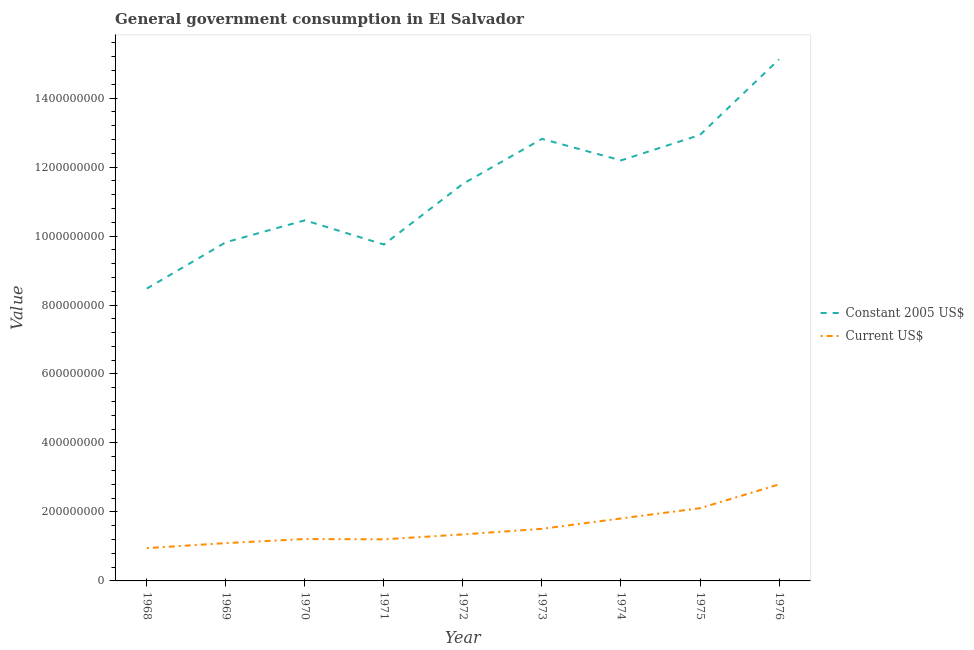How many different coloured lines are there?
Provide a short and direct response. 2. What is the value consumed in constant 2005 us$ in 1973?
Keep it short and to the point. 1.28e+09. Across all years, what is the maximum value consumed in current us$?
Provide a succinct answer. 2.80e+08. Across all years, what is the minimum value consumed in current us$?
Your response must be concise. 9.51e+07. In which year was the value consumed in current us$ maximum?
Offer a very short reply. 1976. In which year was the value consumed in constant 2005 us$ minimum?
Give a very brief answer. 1968. What is the total value consumed in constant 2005 us$ in the graph?
Keep it short and to the point. 1.03e+1. What is the difference between the value consumed in constant 2005 us$ in 1972 and that in 1975?
Your answer should be very brief. -1.42e+08. What is the difference between the value consumed in current us$ in 1972 and the value consumed in constant 2005 us$ in 1975?
Ensure brevity in your answer.  -1.16e+09. What is the average value consumed in current us$ per year?
Offer a very short reply. 1.56e+08. In the year 1975, what is the difference between the value consumed in constant 2005 us$ and value consumed in current us$?
Your answer should be compact. 1.08e+09. In how many years, is the value consumed in constant 2005 us$ greater than 1440000000?
Offer a very short reply. 1. What is the ratio of the value consumed in current us$ in 1973 to that in 1976?
Provide a short and direct response. 0.54. Is the value consumed in constant 2005 us$ in 1970 less than that in 1976?
Provide a succinct answer. Yes. Is the difference between the value consumed in current us$ in 1969 and 1974 greater than the difference between the value consumed in constant 2005 us$ in 1969 and 1974?
Ensure brevity in your answer.  Yes. What is the difference between the highest and the second highest value consumed in constant 2005 us$?
Your response must be concise. 2.19e+08. What is the difference between the highest and the lowest value consumed in current us$?
Ensure brevity in your answer.  1.85e+08. In how many years, is the value consumed in constant 2005 us$ greater than the average value consumed in constant 2005 us$ taken over all years?
Offer a terse response. 5. Is the sum of the value consumed in current us$ in 1969 and 1972 greater than the maximum value consumed in constant 2005 us$ across all years?
Your response must be concise. No. Does the value consumed in constant 2005 us$ monotonically increase over the years?
Ensure brevity in your answer.  No. Is the value consumed in current us$ strictly greater than the value consumed in constant 2005 us$ over the years?
Keep it short and to the point. No. Does the graph contain grids?
Offer a very short reply. No. Where does the legend appear in the graph?
Make the answer very short. Center right. How many legend labels are there?
Offer a terse response. 2. How are the legend labels stacked?
Your response must be concise. Vertical. What is the title of the graph?
Give a very brief answer. General government consumption in El Salvador. Does "Nonresident" appear as one of the legend labels in the graph?
Your response must be concise. No. What is the label or title of the Y-axis?
Your answer should be very brief. Value. What is the Value of Constant 2005 US$ in 1968?
Your answer should be compact. 8.48e+08. What is the Value of Current US$ in 1968?
Your answer should be very brief. 9.51e+07. What is the Value in Constant 2005 US$ in 1969?
Provide a succinct answer. 9.82e+08. What is the Value in Current US$ in 1969?
Offer a very short reply. 1.10e+08. What is the Value of Constant 2005 US$ in 1970?
Ensure brevity in your answer.  1.05e+09. What is the Value of Current US$ in 1970?
Keep it short and to the point. 1.21e+08. What is the Value of Constant 2005 US$ in 1971?
Make the answer very short. 9.75e+08. What is the Value of Current US$ in 1971?
Provide a short and direct response. 1.21e+08. What is the Value in Constant 2005 US$ in 1972?
Offer a very short reply. 1.15e+09. What is the Value in Current US$ in 1972?
Provide a short and direct response. 1.35e+08. What is the Value in Constant 2005 US$ in 1973?
Make the answer very short. 1.28e+09. What is the Value of Current US$ in 1973?
Offer a terse response. 1.51e+08. What is the Value in Constant 2005 US$ in 1974?
Keep it short and to the point. 1.22e+09. What is the Value in Current US$ in 1974?
Give a very brief answer. 1.81e+08. What is the Value of Constant 2005 US$ in 1975?
Your response must be concise. 1.29e+09. What is the Value in Current US$ in 1975?
Provide a short and direct response. 2.11e+08. What is the Value in Constant 2005 US$ in 1976?
Offer a terse response. 1.51e+09. What is the Value in Current US$ in 1976?
Provide a succinct answer. 2.80e+08. Across all years, what is the maximum Value of Constant 2005 US$?
Offer a very short reply. 1.51e+09. Across all years, what is the maximum Value in Current US$?
Make the answer very short. 2.80e+08. Across all years, what is the minimum Value of Constant 2005 US$?
Offer a terse response. 8.48e+08. Across all years, what is the minimum Value of Current US$?
Provide a succinct answer. 9.51e+07. What is the total Value in Constant 2005 US$ in the graph?
Keep it short and to the point. 1.03e+1. What is the total Value in Current US$ in the graph?
Provide a succinct answer. 1.40e+09. What is the difference between the Value in Constant 2005 US$ in 1968 and that in 1969?
Provide a short and direct response. -1.34e+08. What is the difference between the Value of Current US$ in 1968 and that in 1969?
Keep it short and to the point. -1.46e+07. What is the difference between the Value in Constant 2005 US$ in 1968 and that in 1970?
Offer a terse response. -1.98e+08. What is the difference between the Value in Current US$ in 1968 and that in 1970?
Give a very brief answer. -2.64e+07. What is the difference between the Value of Constant 2005 US$ in 1968 and that in 1971?
Make the answer very short. -1.28e+08. What is the difference between the Value in Current US$ in 1968 and that in 1971?
Keep it short and to the point. -2.55e+07. What is the difference between the Value in Constant 2005 US$ in 1968 and that in 1972?
Give a very brief answer. -3.04e+08. What is the difference between the Value in Current US$ in 1968 and that in 1972?
Keep it short and to the point. -3.98e+07. What is the difference between the Value in Constant 2005 US$ in 1968 and that in 1973?
Keep it short and to the point. -4.34e+08. What is the difference between the Value of Current US$ in 1968 and that in 1973?
Keep it short and to the point. -5.60e+07. What is the difference between the Value of Constant 2005 US$ in 1968 and that in 1974?
Give a very brief answer. -3.72e+08. What is the difference between the Value in Current US$ in 1968 and that in 1974?
Your response must be concise. -8.60e+07. What is the difference between the Value of Constant 2005 US$ in 1968 and that in 1975?
Provide a short and direct response. -4.46e+08. What is the difference between the Value in Current US$ in 1968 and that in 1975?
Give a very brief answer. -1.16e+08. What is the difference between the Value in Constant 2005 US$ in 1968 and that in 1976?
Give a very brief answer. -6.65e+08. What is the difference between the Value in Current US$ in 1968 and that in 1976?
Give a very brief answer. -1.85e+08. What is the difference between the Value in Constant 2005 US$ in 1969 and that in 1970?
Keep it short and to the point. -6.37e+07. What is the difference between the Value of Current US$ in 1969 and that in 1970?
Ensure brevity in your answer.  -1.18e+07. What is the difference between the Value in Constant 2005 US$ in 1969 and that in 1971?
Provide a short and direct response. 6.57e+06. What is the difference between the Value in Current US$ in 1969 and that in 1971?
Provide a short and direct response. -1.10e+07. What is the difference between the Value of Constant 2005 US$ in 1969 and that in 1972?
Provide a succinct answer. -1.69e+08. What is the difference between the Value in Current US$ in 1969 and that in 1972?
Your response must be concise. -2.52e+07. What is the difference between the Value in Constant 2005 US$ in 1969 and that in 1973?
Your answer should be very brief. -3.00e+08. What is the difference between the Value in Current US$ in 1969 and that in 1973?
Provide a short and direct response. -4.14e+07. What is the difference between the Value of Constant 2005 US$ in 1969 and that in 1974?
Provide a short and direct response. -2.37e+08. What is the difference between the Value in Current US$ in 1969 and that in 1974?
Provide a succinct answer. -7.15e+07. What is the difference between the Value of Constant 2005 US$ in 1969 and that in 1975?
Your response must be concise. -3.11e+08. What is the difference between the Value in Current US$ in 1969 and that in 1975?
Your answer should be compact. -1.01e+08. What is the difference between the Value of Constant 2005 US$ in 1969 and that in 1976?
Give a very brief answer. -5.30e+08. What is the difference between the Value in Current US$ in 1969 and that in 1976?
Ensure brevity in your answer.  -1.70e+08. What is the difference between the Value in Constant 2005 US$ in 1970 and that in 1971?
Offer a terse response. 7.02e+07. What is the difference between the Value in Current US$ in 1970 and that in 1971?
Offer a terse response. 8.80e+05. What is the difference between the Value in Constant 2005 US$ in 1970 and that in 1972?
Provide a succinct answer. -1.06e+08. What is the difference between the Value of Current US$ in 1970 and that in 1972?
Ensure brevity in your answer.  -1.34e+07. What is the difference between the Value in Constant 2005 US$ in 1970 and that in 1973?
Make the answer very short. -2.36e+08. What is the difference between the Value in Current US$ in 1970 and that in 1973?
Keep it short and to the point. -2.96e+07. What is the difference between the Value of Constant 2005 US$ in 1970 and that in 1974?
Give a very brief answer. -1.74e+08. What is the difference between the Value of Current US$ in 1970 and that in 1974?
Ensure brevity in your answer.  -5.96e+07. What is the difference between the Value in Constant 2005 US$ in 1970 and that in 1975?
Keep it short and to the point. -2.48e+08. What is the difference between the Value in Current US$ in 1970 and that in 1975?
Give a very brief answer. -8.94e+07. What is the difference between the Value of Constant 2005 US$ in 1970 and that in 1976?
Give a very brief answer. -4.67e+08. What is the difference between the Value of Current US$ in 1970 and that in 1976?
Make the answer very short. -1.58e+08. What is the difference between the Value in Constant 2005 US$ in 1971 and that in 1972?
Provide a succinct answer. -1.76e+08. What is the difference between the Value in Current US$ in 1971 and that in 1972?
Offer a terse response. -1.42e+07. What is the difference between the Value in Constant 2005 US$ in 1971 and that in 1973?
Your response must be concise. -3.06e+08. What is the difference between the Value of Current US$ in 1971 and that in 1973?
Offer a terse response. -3.05e+07. What is the difference between the Value of Constant 2005 US$ in 1971 and that in 1974?
Offer a very short reply. -2.44e+08. What is the difference between the Value of Current US$ in 1971 and that in 1974?
Keep it short and to the point. -6.05e+07. What is the difference between the Value in Constant 2005 US$ in 1971 and that in 1975?
Provide a succinct answer. -3.18e+08. What is the difference between the Value of Current US$ in 1971 and that in 1975?
Your response must be concise. -9.03e+07. What is the difference between the Value of Constant 2005 US$ in 1971 and that in 1976?
Your answer should be compact. -5.37e+08. What is the difference between the Value in Current US$ in 1971 and that in 1976?
Your answer should be very brief. -1.59e+08. What is the difference between the Value of Constant 2005 US$ in 1972 and that in 1973?
Ensure brevity in your answer.  -1.30e+08. What is the difference between the Value in Current US$ in 1972 and that in 1973?
Give a very brief answer. -1.62e+07. What is the difference between the Value in Constant 2005 US$ in 1972 and that in 1974?
Your response must be concise. -6.79e+07. What is the difference between the Value in Current US$ in 1972 and that in 1974?
Offer a very short reply. -4.63e+07. What is the difference between the Value of Constant 2005 US$ in 1972 and that in 1975?
Ensure brevity in your answer.  -1.42e+08. What is the difference between the Value in Current US$ in 1972 and that in 1975?
Your answer should be very brief. -7.60e+07. What is the difference between the Value in Constant 2005 US$ in 1972 and that in 1976?
Provide a short and direct response. -3.61e+08. What is the difference between the Value of Current US$ in 1972 and that in 1976?
Your response must be concise. -1.45e+08. What is the difference between the Value in Constant 2005 US$ in 1973 and that in 1974?
Offer a very short reply. 6.24e+07. What is the difference between the Value of Current US$ in 1973 and that in 1974?
Keep it short and to the point. -3.00e+07. What is the difference between the Value of Constant 2005 US$ in 1973 and that in 1975?
Offer a very short reply. -1.15e+07. What is the difference between the Value of Current US$ in 1973 and that in 1975?
Provide a succinct answer. -5.98e+07. What is the difference between the Value of Constant 2005 US$ in 1973 and that in 1976?
Make the answer very short. -2.31e+08. What is the difference between the Value of Current US$ in 1973 and that in 1976?
Your response must be concise. -1.29e+08. What is the difference between the Value in Constant 2005 US$ in 1974 and that in 1975?
Keep it short and to the point. -7.39e+07. What is the difference between the Value in Current US$ in 1974 and that in 1975?
Provide a short and direct response. -2.98e+07. What is the difference between the Value of Constant 2005 US$ in 1974 and that in 1976?
Ensure brevity in your answer.  -2.93e+08. What is the difference between the Value in Current US$ in 1974 and that in 1976?
Ensure brevity in your answer.  -9.88e+07. What is the difference between the Value of Constant 2005 US$ in 1975 and that in 1976?
Give a very brief answer. -2.19e+08. What is the difference between the Value in Current US$ in 1975 and that in 1976?
Make the answer very short. -6.90e+07. What is the difference between the Value of Constant 2005 US$ in 1968 and the Value of Current US$ in 1969?
Make the answer very short. 7.38e+08. What is the difference between the Value in Constant 2005 US$ in 1968 and the Value in Current US$ in 1970?
Offer a terse response. 7.26e+08. What is the difference between the Value in Constant 2005 US$ in 1968 and the Value in Current US$ in 1971?
Ensure brevity in your answer.  7.27e+08. What is the difference between the Value of Constant 2005 US$ in 1968 and the Value of Current US$ in 1972?
Your response must be concise. 7.13e+08. What is the difference between the Value of Constant 2005 US$ in 1968 and the Value of Current US$ in 1973?
Make the answer very short. 6.97e+08. What is the difference between the Value of Constant 2005 US$ in 1968 and the Value of Current US$ in 1974?
Provide a short and direct response. 6.66e+08. What is the difference between the Value in Constant 2005 US$ in 1968 and the Value in Current US$ in 1975?
Your answer should be compact. 6.37e+08. What is the difference between the Value in Constant 2005 US$ in 1968 and the Value in Current US$ in 1976?
Offer a very short reply. 5.68e+08. What is the difference between the Value of Constant 2005 US$ in 1969 and the Value of Current US$ in 1970?
Make the answer very short. 8.60e+08. What is the difference between the Value in Constant 2005 US$ in 1969 and the Value in Current US$ in 1971?
Offer a terse response. 8.61e+08. What is the difference between the Value of Constant 2005 US$ in 1969 and the Value of Current US$ in 1972?
Give a very brief answer. 8.47e+08. What is the difference between the Value in Constant 2005 US$ in 1969 and the Value in Current US$ in 1973?
Provide a succinct answer. 8.31e+08. What is the difference between the Value in Constant 2005 US$ in 1969 and the Value in Current US$ in 1974?
Keep it short and to the point. 8.01e+08. What is the difference between the Value of Constant 2005 US$ in 1969 and the Value of Current US$ in 1975?
Your answer should be very brief. 7.71e+08. What is the difference between the Value in Constant 2005 US$ in 1969 and the Value in Current US$ in 1976?
Give a very brief answer. 7.02e+08. What is the difference between the Value of Constant 2005 US$ in 1970 and the Value of Current US$ in 1971?
Keep it short and to the point. 9.25e+08. What is the difference between the Value in Constant 2005 US$ in 1970 and the Value in Current US$ in 1972?
Your answer should be very brief. 9.11e+08. What is the difference between the Value of Constant 2005 US$ in 1970 and the Value of Current US$ in 1973?
Provide a succinct answer. 8.95e+08. What is the difference between the Value in Constant 2005 US$ in 1970 and the Value in Current US$ in 1974?
Your answer should be compact. 8.65e+08. What is the difference between the Value of Constant 2005 US$ in 1970 and the Value of Current US$ in 1975?
Keep it short and to the point. 8.35e+08. What is the difference between the Value of Constant 2005 US$ in 1970 and the Value of Current US$ in 1976?
Your response must be concise. 7.66e+08. What is the difference between the Value of Constant 2005 US$ in 1971 and the Value of Current US$ in 1972?
Make the answer very short. 8.41e+08. What is the difference between the Value of Constant 2005 US$ in 1971 and the Value of Current US$ in 1973?
Offer a very short reply. 8.24e+08. What is the difference between the Value in Constant 2005 US$ in 1971 and the Value in Current US$ in 1974?
Your answer should be compact. 7.94e+08. What is the difference between the Value in Constant 2005 US$ in 1971 and the Value in Current US$ in 1975?
Make the answer very short. 7.65e+08. What is the difference between the Value in Constant 2005 US$ in 1971 and the Value in Current US$ in 1976?
Ensure brevity in your answer.  6.96e+08. What is the difference between the Value in Constant 2005 US$ in 1972 and the Value in Current US$ in 1973?
Offer a very short reply. 1.00e+09. What is the difference between the Value of Constant 2005 US$ in 1972 and the Value of Current US$ in 1974?
Provide a succinct answer. 9.70e+08. What is the difference between the Value in Constant 2005 US$ in 1972 and the Value in Current US$ in 1975?
Provide a succinct answer. 9.41e+08. What is the difference between the Value in Constant 2005 US$ in 1972 and the Value in Current US$ in 1976?
Your answer should be compact. 8.72e+08. What is the difference between the Value of Constant 2005 US$ in 1973 and the Value of Current US$ in 1974?
Your response must be concise. 1.10e+09. What is the difference between the Value of Constant 2005 US$ in 1973 and the Value of Current US$ in 1975?
Make the answer very short. 1.07e+09. What is the difference between the Value in Constant 2005 US$ in 1973 and the Value in Current US$ in 1976?
Offer a very short reply. 1.00e+09. What is the difference between the Value of Constant 2005 US$ in 1974 and the Value of Current US$ in 1975?
Your answer should be compact. 1.01e+09. What is the difference between the Value in Constant 2005 US$ in 1974 and the Value in Current US$ in 1976?
Make the answer very short. 9.39e+08. What is the difference between the Value of Constant 2005 US$ in 1975 and the Value of Current US$ in 1976?
Make the answer very short. 1.01e+09. What is the average Value in Constant 2005 US$ per year?
Your response must be concise. 1.15e+09. What is the average Value in Current US$ per year?
Your response must be concise. 1.56e+08. In the year 1968, what is the difference between the Value of Constant 2005 US$ and Value of Current US$?
Offer a very short reply. 7.53e+08. In the year 1969, what is the difference between the Value of Constant 2005 US$ and Value of Current US$?
Make the answer very short. 8.72e+08. In the year 1970, what is the difference between the Value of Constant 2005 US$ and Value of Current US$?
Offer a terse response. 9.24e+08. In the year 1971, what is the difference between the Value in Constant 2005 US$ and Value in Current US$?
Offer a terse response. 8.55e+08. In the year 1972, what is the difference between the Value of Constant 2005 US$ and Value of Current US$?
Keep it short and to the point. 1.02e+09. In the year 1973, what is the difference between the Value in Constant 2005 US$ and Value in Current US$?
Your answer should be very brief. 1.13e+09. In the year 1974, what is the difference between the Value of Constant 2005 US$ and Value of Current US$?
Offer a terse response. 1.04e+09. In the year 1975, what is the difference between the Value of Constant 2005 US$ and Value of Current US$?
Your answer should be compact. 1.08e+09. In the year 1976, what is the difference between the Value in Constant 2005 US$ and Value in Current US$?
Provide a succinct answer. 1.23e+09. What is the ratio of the Value of Constant 2005 US$ in 1968 to that in 1969?
Keep it short and to the point. 0.86. What is the ratio of the Value in Current US$ in 1968 to that in 1969?
Your answer should be very brief. 0.87. What is the ratio of the Value in Constant 2005 US$ in 1968 to that in 1970?
Keep it short and to the point. 0.81. What is the ratio of the Value in Current US$ in 1968 to that in 1970?
Give a very brief answer. 0.78. What is the ratio of the Value of Constant 2005 US$ in 1968 to that in 1971?
Your response must be concise. 0.87. What is the ratio of the Value of Current US$ in 1968 to that in 1971?
Keep it short and to the point. 0.79. What is the ratio of the Value in Constant 2005 US$ in 1968 to that in 1972?
Make the answer very short. 0.74. What is the ratio of the Value in Current US$ in 1968 to that in 1972?
Offer a very short reply. 0.71. What is the ratio of the Value in Constant 2005 US$ in 1968 to that in 1973?
Keep it short and to the point. 0.66. What is the ratio of the Value of Current US$ in 1968 to that in 1973?
Offer a terse response. 0.63. What is the ratio of the Value in Constant 2005 US$ in 1968 to that in 1974?
Ensure brevity in your answer.  0.7. What is the ratio of the Value of Current US$ in 1968 to that in 1974?
Your answer should be very brief. 0.53. What is the ratio of the Value in Constant 2005 US$ in 1968 to that in 1975?
Offer a terse response. 0.66. What is the ratio of the Value of Current US$ in 1968 to that in 1975?
Your answer should be very brief. 0.45. What is the ratio of the Value in Constant 2005 US$ in 1968 to that in 1976?
Offer a terse response. 0.56. What is the ratio of the Value of Current US$ in 1968 to that in 1976?
Offer a terse response. 0.34. What is the ratio of the Value of Constant 2005 US$ in 1969 to that in 1970?
Provide a short and direct response. 0.94. What is the ratio of the Value in Current US$ in 1969 to that in 1970?
Provide a short and direct response. 0.9. What is the ratio of the Value of Current US$ in 1969 to that in 1971?
Make the answer very short. 0.91. What is the ratio of the Value in Constant 2005 US$ in 1969 to that in 1972?
Provide a succinct answer. 0.85. What is the ratio of the Value of Current US$ in 1969 to that in 1972?
Provide a succinct answer. 0.81. What is the ratio of the Value in Constant 2005 US$ in 1969 to that in 1973?
Offer a very short reply. 0.77. What is the ratio of the Value in Current US$ in 1969 to that in 1973?
Give a very brief answer. 0.73. What is the ratio of the Value in Constant 2005 US$ in 1969 to that in 1974?
Your answer should be compact. 0.81. What is the ratio of the Value in Current US$ in 1969 to that in 1974?
Offer a terse response. 0.61. What is the ratio of the Value in Constant 2005 US$ in 1969 to that in 1975?
Make the answer very short. 0.76. What is the ratio of the Value of Current US$ in 1969 to that in 1975?
Your response must be concise. 0.52. What is the ratio of the Value in Constant 2005 US$ in 1969 to that in 1976?
Give a very brief answer. 0.65. What is the ratio of the Value in Current US$ in 1969 to that in 1976?
Offer a terse response. 0.39. What is the ratio of the Value of Constant 2005 US$ in 1970 to that in 1971?
Your response must be concise. 1.07. What is the ratio of the Value in Current US$ in 1970 to that in 1971?
Ensure brevity in your answer.  1.01. What is the ratio of the Value in Constant 2005 US$ in 1970 to that in 1972?
Keep it short and to the point. 0.91. What is the ratio of the Value of Current US$ in 1970 to that in 1972?
Keep it short and to the point. 0.9. What is the ratio of the Value of Constant 2005 US$ in 1970 to that in 1973?
Keep it short and to the point. 0.82. What is the ratio of the Value in Current US$ in 1970 to that in 1973?
Make the answer very short. 0.8. What is the ratio of the Value of Constant 2005 US$ in 1970 to that in 1974?
Ensure brevity in your answer.  0.86. What is the ratio of the Value of Current US$ in 1970 to that in 1974?
Make the answer very short. 0.67. What is the ratio of the Value in Constant 2005 US$ in 1970 to that in 1975?
Keep it short and to the point. 0.81. What is the ratio of the Value of Current US$ in 1970 to that in 1975?
Ensure brevity in your answer.  0.58. What is the ratio of the Value of Constant 2005 US$ in 1970 to that in 1976?
Ensure brevity in your answer.  0.69. What is the ratio of the Value of Current US$ in 1970 to that in 1976?
Give a very brief answer. 0.43. What is the ratio of the Value of Constant 2005 US$ in 1971 to that in 1972?
Provide a succinct answer. 0.85. What is the ratio of the Value in Current US$ in 1971 to that in 1972?
Your answer should be compact. 0.89. What is the ratio of the Value of Constant 2005 US$ in 1971 to that in 1973?
Offer a terse response. 0.76. What is the ratio of the Value of Current US$ in 1971 to that in 1973?
Your response must be concise. 0.8. What is the ratio of the Value of Constant 2005 US$ in 1971 to that in 1974?
Offer a very short reply. 0.8. What is the ratio of the Value of Current US$ in 1971 to that in 1974?
Your answer should be very brief. 0.67. What is the ratio of the Value of Constant 2005 US$ in 1971 to that in 1975?
Keep it short and to the point. 0.75. What is the ratio of the Value of Current US$ in 1971 to that in 1975?
Provide a short and direct response. 0.57. What is the ratio of the Value in Constant 2005 US$ in 1971 to that in 1976?
Provide a succinct answer. 0.64. What is the ratio of the Value of Current US$ in 1971 to that in 1976?
Your answer should be compact. 0.43. What is the ratio of the Value in Constant 2005 US$ in 1972 to that in 1973?
Ensure brevity in your answer.  0.9. What is the ratio of the Value of Current US$ in 1972 to that in 1973?
Offer a terse response. 0.89. What is the ratio of the Value of Constant 2005 US$ in 1972 to that in 1974?
Ensure brevity in your answer.  0.94. What is the ratio of the Value of Current US$ in 1972 to that in 1974?
Keep it short and to the point. 0.74. What is the ratio of the Value of Constant 2005 US$ in 1972 to that in 1975?
Give a very brief answer. 0.89. What is the ratio of the Value in Current US$ in 1972 to that in 1975?
Provide a succinct answer. 0.64. What is the ratio of the Value in Constant 2005 US$ in 1972 to that in 1976?
Ensure brevity in your answer.  0.76. What is the ratio of the Value in Current US$ in 1972 to that in 1976?
Ensure brevity in your answer.  0.48. What is the ratio of the Value of Constant 2005 US$ in 1973 to that in 1974?
Your answer should be compact. 1.05. What is the ratio of the Value of Current US$ in 1973 to that in 1974?
Your answer should be compact. 0.83. What is the ratio of the Value of Constant 2005 US$ in 1973 to that in 1975?
Your answer should be compact. 0.99. What is the ratio of the Value of Current US$ in 1973 to that in 1975?
Your answer should be very brief. 0.72. What is the ratio of the Value of Constant 2005 US$ in 1973 to that in 1976?
Keep it short and to the point. 0.85. What is the ratio of the Value of Current US$ in 1973 to that in 1976?
Keep it short and to the point. 0.54. What is the ratio of the Value of Constant 2005 US$ in 1974 to that in 1975?
Make the answer very short. 0.94. What is the ratio of the Value in Current US$ in 1974 to that in 1975?
Offer a very short reply. 0.86. What is the ratio of the Value in Constant 2005 US$ in 1974 to that in 1976?
Make the answer very short. 0.81. What is the ratio of the Value in Current US$ in 1974 to that in 1976?
Offer a terse response. 0.65. What is the ratio of the Value of Constant 2005 US$ in 1975 to that in 1976?
Keep it short and to the point. 0.86. What is the ratio of the Value of Current US$ in 1975 to that in 1976?
Give a very brief answer. 0.75. What is the difference between the highest and the second highest Value in Constant 2005 US$?
Offer a very short reply. 2.19e+08. What is the difference between the highest and the second highest Value of Current US$?
Keep it short and to the point. 6.90e+07. What is the difference between the highest and the lowest Value of Constant 2005 US$?
Offer a very short reply. 6.65e+08. What is the difference between the highest and the lowest Value in Current US$?
Provide a short and direct response. 1.85e+08. 